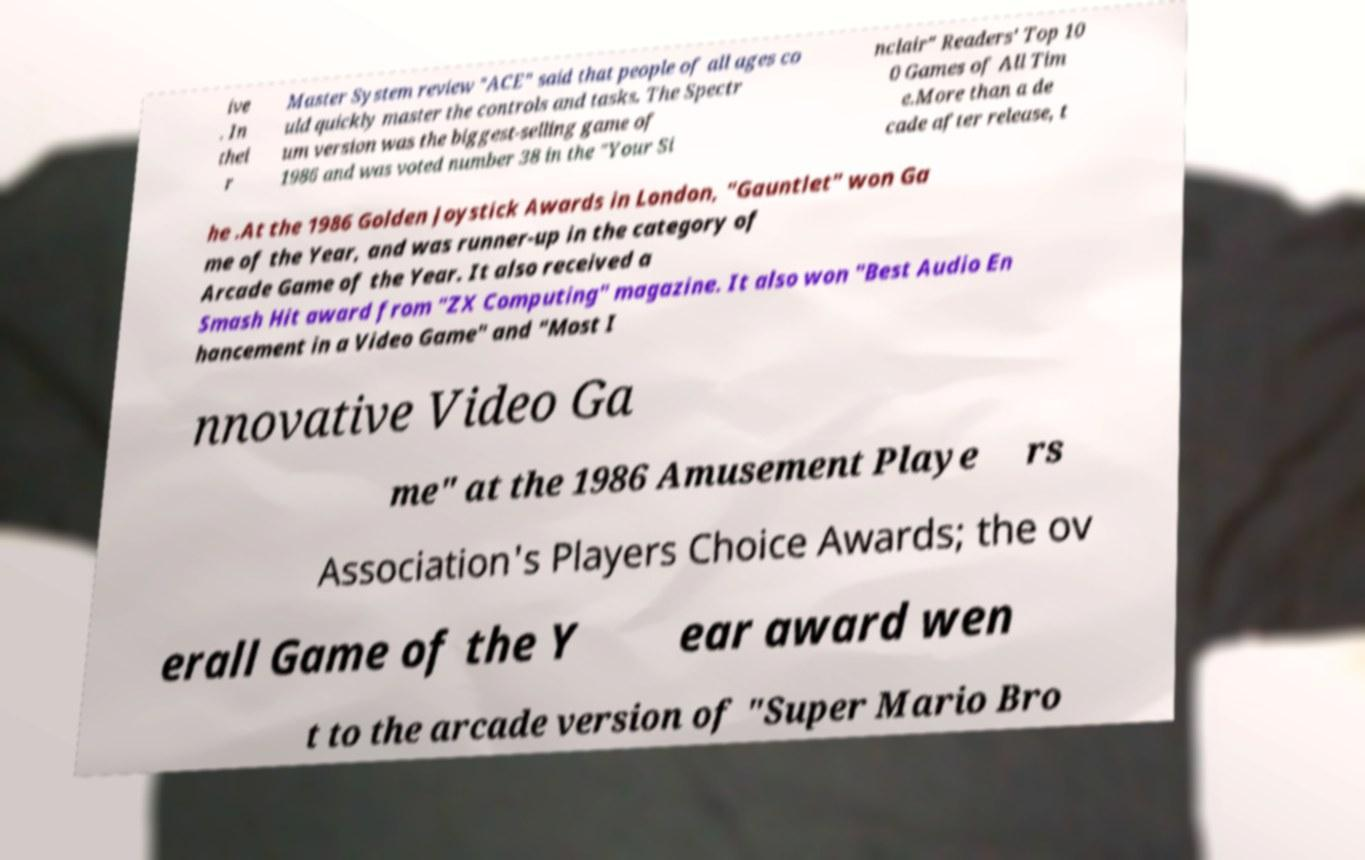What messages or text are displayed in this image? I need them in a readable, typed format. ive . In thei r Master System review "ACE" said that people of all ages co uld quickly master the controls and tasks. The Spectr um version was the biggest-selling game of 1986 and was voted number 38 in the "Your Si nclair" Readers' Top 10 0 Games of All Tim e.More than a de cade after release, t he .At the 1986 Golden Joystick Awards in London, "Gauntlet" won Ga me of the Year, and was runner-up in the category of Arcade Game of the Year. It also received a Smash Hit award from "ZX Computing" magazine. It also won "Best Audio En hancement in a Video Game" and "Most I nnovative Video Ga me" at the 1986 Amusement Playe rs Association's Players Choice Awards; the ov erall Game of the Y ear award wen t to the arcade version of "Super Mario Bro 